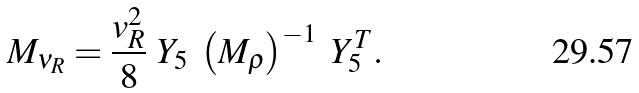<formula> <loc_0><loc_0><loc_500><loc_500>M _ { \nu _ { R } } = \frac { v _ { R } ^ { 2 } } { 8 } \ Y _ { 5 } \ \left ( M _ { \rho } \right ) ^ { - 1 } \ Y _ { 5 } ^ { T } .</formula> 